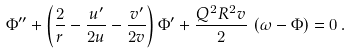Convert formula to latex. <formula><loc_0><loc_0><loc_500><loc_500>\Phi ^ { \prime \prime } + \left ( \frac { 2 } { r } - \frac { u ^ { \prime } } { 2 u } - \frac { v ^ { \prime } } { 2 v } \right ) \Phi ^ { \prime } + \frac { Q ^ { 2 } R ^ { 2 } v } { 2 } \, \left ( \omega - \Phi \right ) = 0 \, .</formula> 